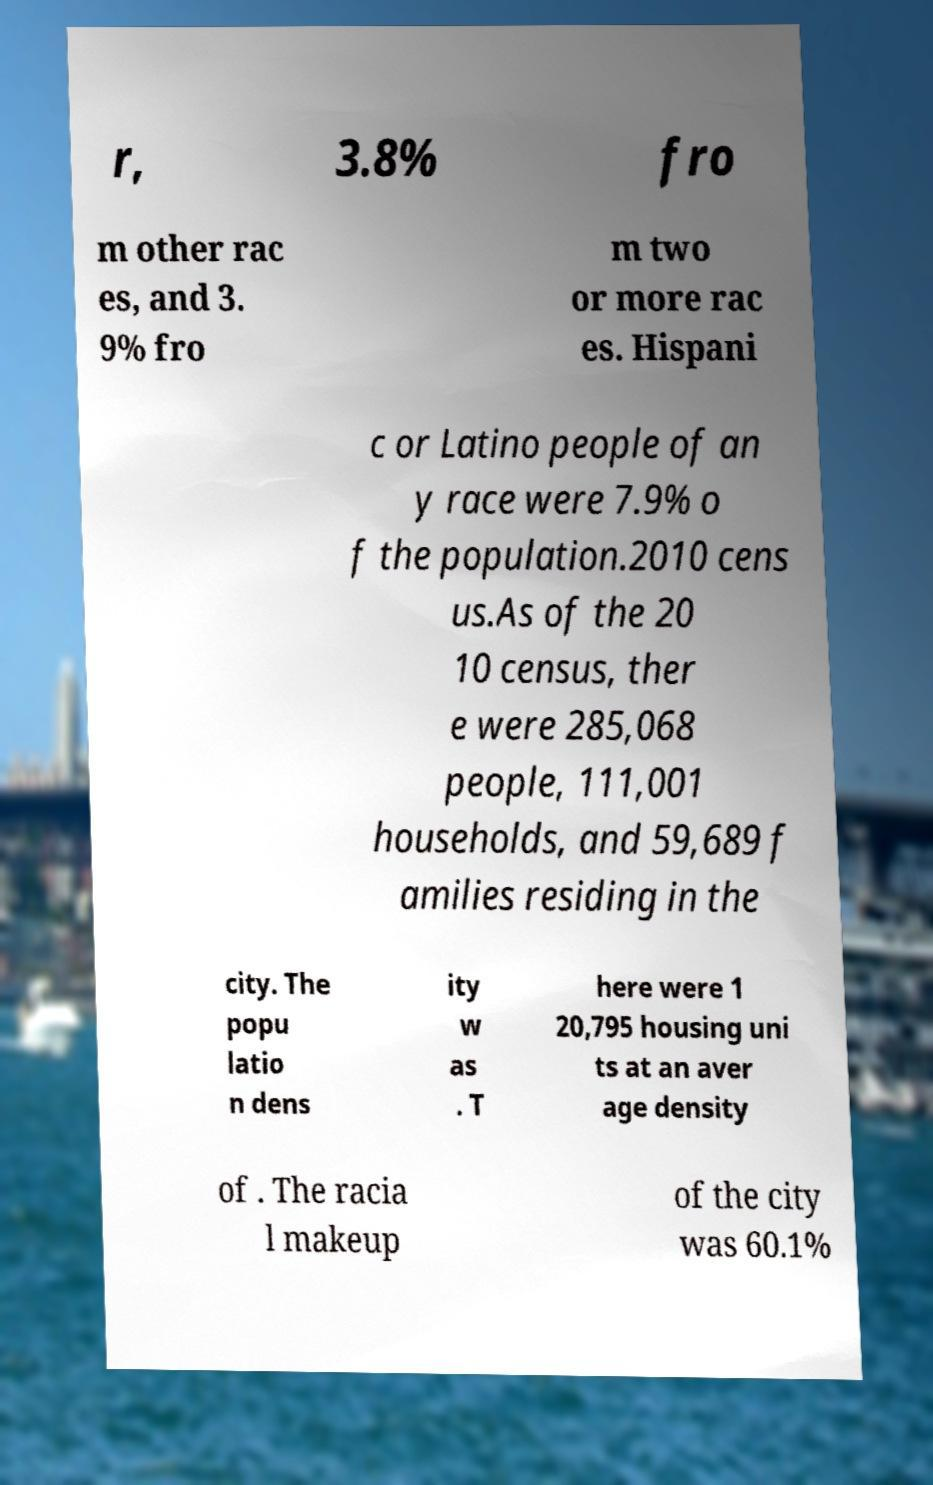Can you read and provide the text displayed in the image?This photo seems to have some interesting text. Can you extract and type it out for me? r, 3.8% fro m other rac es, and 3. 9% fro m two or more rac es. Hispani c or Latino people of an y race were 7.9% o f the population.2010 cens us.As of the 20 10 census, ther e were 285,068 people, 111,001 households, and 59,689 f amilies residing in the city. The popu latio n dens ity w as . T here were 1 20,795 housing uni ts at an aver age density of . The racia l makeup of the city was 60.1% 